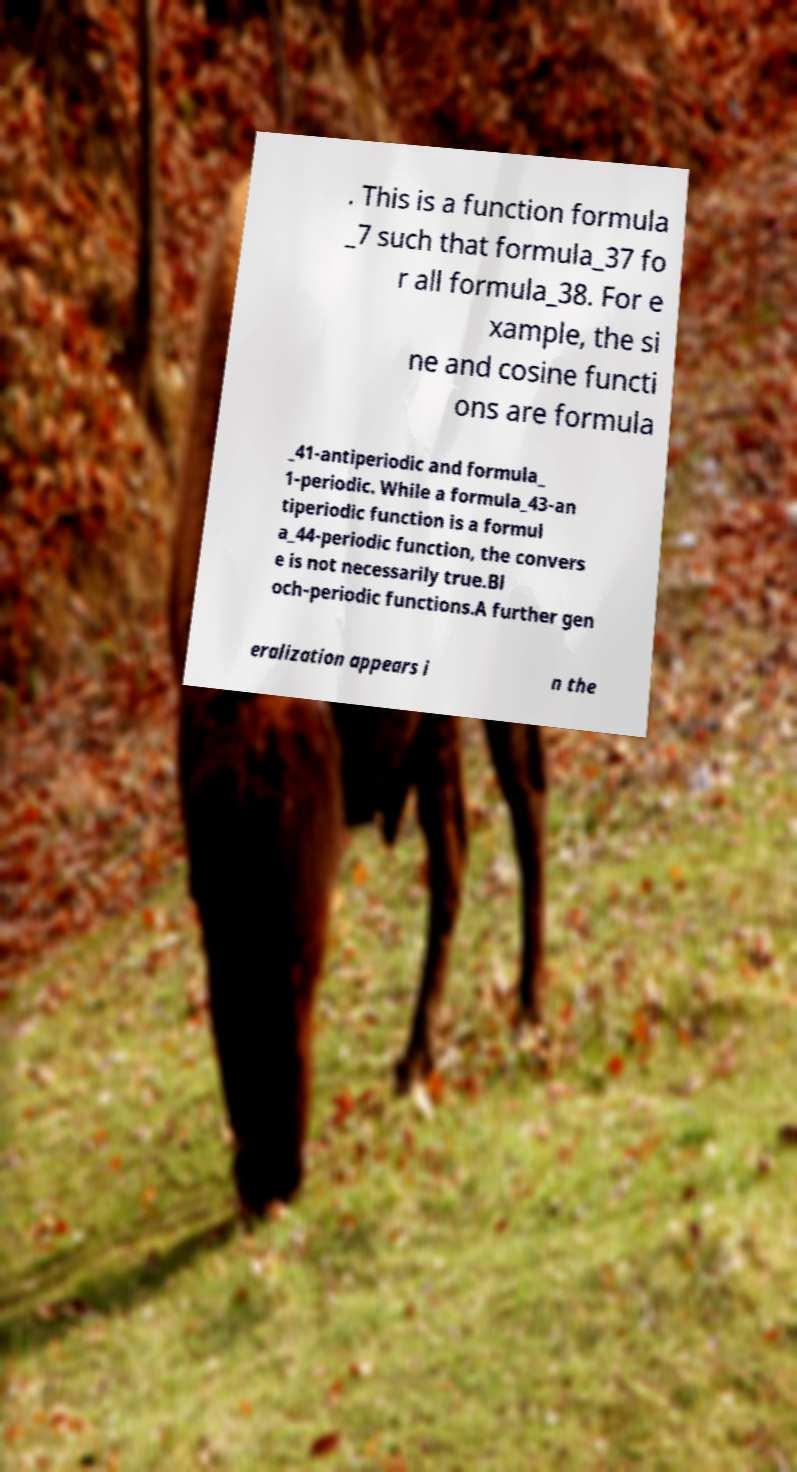For documentation purposes, I need the text within this image transcribed. Could you provide that? . This is a function formula _7 such that formula_37 fo r all formula_38. For e xample, the si ne and cosine functi ons are formula _41-antiperiodic and formula_ 1-periodic. While a formula_43-an tiperiodic function is a formul a_44-periodic function, the convers e is not necessarily true.Bl och-periodic functions.A further gen eralization appears i n the 